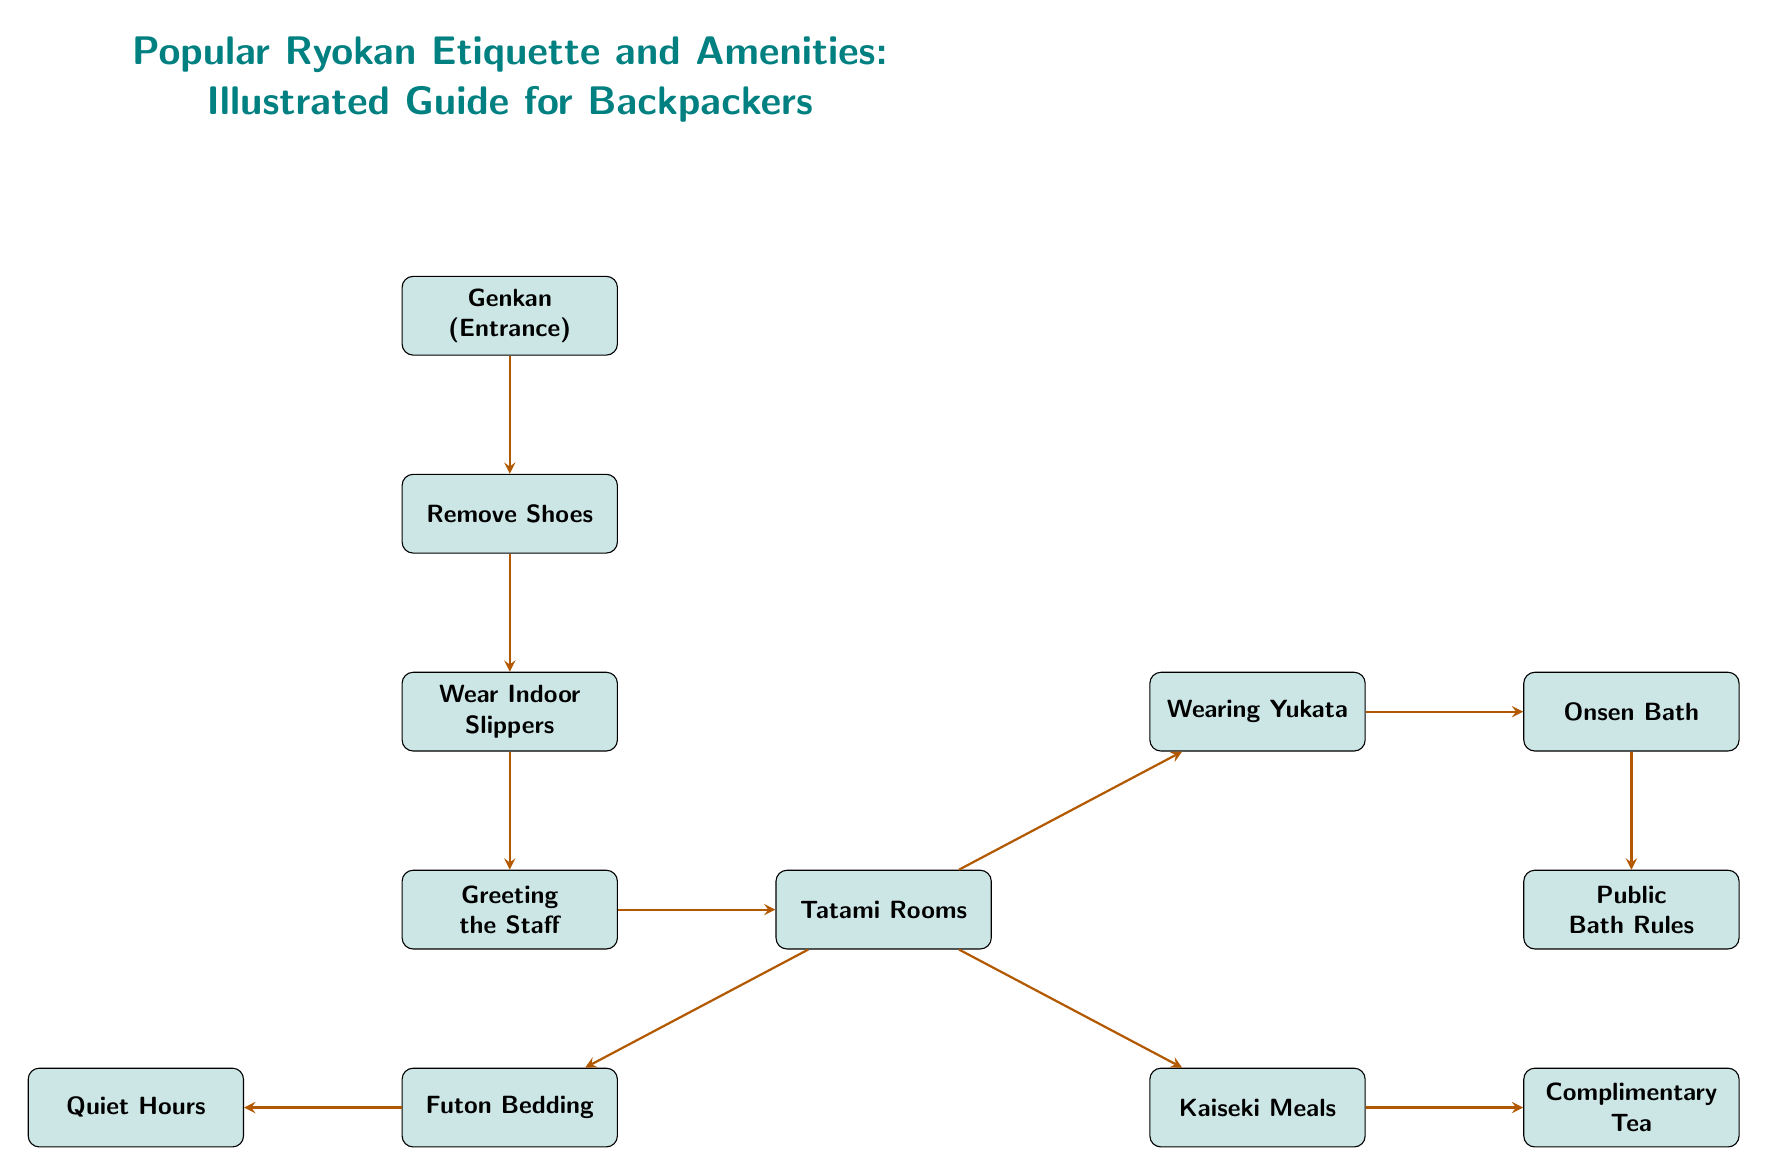What is the first step upon entering the ryokan? The diagram indicates that the first step is to go to the Genkan (Entrance), which is the initial point before proceeding with any further etiquette.
Answer: Genkan (Entrance) How many main nodes are represented in the diagram? By counting each distinct box in the diagram, we can see that there are 10 main nodes detailing different aspects of ryokan etiquette and amenities.
Answer: 10 What do you do after removing your shoes? According to the flow of the diagram, after removing your shoes, the next step is to wear indoor slippers, which are associated with the practice within the ryokan environment.
Answer: Wear Indoor Slippers What is served after kaiseki meals? The diagram shows that complimentary tea is served after the meals, indicating a customary practice following the dining experience at the ryokan.
Answer: Complimentary Tea What must you follow in the onsen bath? The diagram indicates that public bath rules must be followed in the onsen bath, which is crucial for maintaining the etiquette expected in these shared spaces.
Answer: Public Bath Rules Which amenity comes before bedding in the flow? Looking at the diagram, bedding comes after the tatami rooms, so the correct answer is tatami rooms, which serves as the context for where bedding is provided.
Answer: Tatami Rooms What attire is recommended to wear in the ryokan? The diagram points out that wearing a yukata is a customary, casual attire to be donned when participating in activities within the ryokan, especially during night-time.
Answer: Wearing Yukata How does one show respect after entering the ryokan? The initial flow from the entrance to the greeting section signifies that greeting the staff is the way to show respect, which is a vital part of the ryokan experience.
Answer: Greeting the Staff What does the quiet hours node signify? The quiet hours node in the diagram indicates the time frame during which guests are expected to maintain silence to ensure a peaceful atmosphere within the ryokan.
Answer: Quiet Hours 